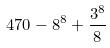<formula> <loc_0><loc_0><loc_500><loc_500>4 7 0 - 8 ^ { 8 } + \frac { 3 ^ { 8 } } { 8 }</formula> 